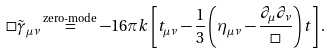Convert formula to latex. <formula><loc_0><loc_0><loc_500><loc_500>\Box \tilde { \gamma } _ { \mu \nu } \overset { \text {zero-mode} } { = } - 1 6 \pi k \left [ t _ { \mu \nu } - \frac { 1 } { 3 } \left ( \eta _ { \mu \nu } - \frac { \partial _ { \mu } \partial _ { \nu } } { \Box } \right ) t \right ] .</formula> 